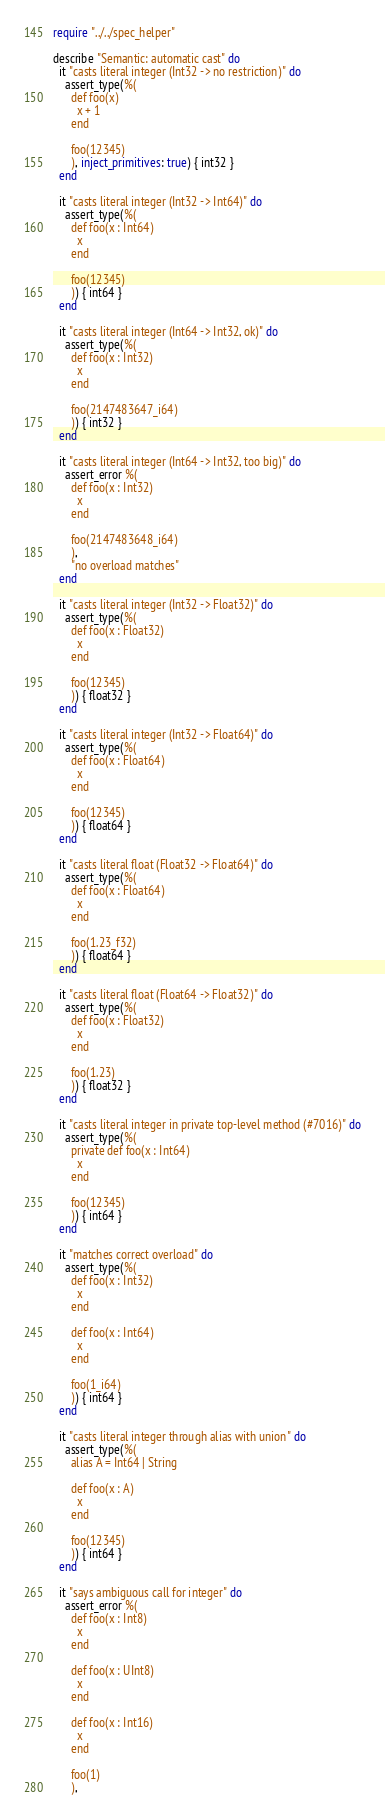<code> <loc_0><loc_0><loc_500><loc_500><_Crystal_>require "../../spec_helper"

describe "Semantic: automatic cast" do
  it "casts literal integer (Int32 -> no restriction)" do
    assert_type(%(
      def foo(x)
        x + 1
      end

      foo(12345)
      ), inject_primitives: true) { int32 }
  end

  it "casts literal integer (Int32 -> Int64)" do
    assert_type(%(
      def foo(x : Int64)
        x
      end

      foo(12345)
      )) { int64 }
  end

  it "casts literal integer (Int64 -> Int32, ok)" do
    assert_type(%(
      def foo(x : Int32)
        x
      end

      foo(2147483647_i64)
      )) { int32 }
  end

  it "casts literal integer (Int64 -> Int32, too big)" do
    assert_error %(
      def foo(x : Int32)
        x
      end

      foo(2147483648_i64)
      ),
      "no overload matches"
  end

  it "casts literal integer (Int32 -> Float32)" do
    assert_type(%(
      def foo(x : Float32)
        x
      end

      foo(12345)
      )) { float32 }
  end

  it "casts literal integer (Int32 -> Float64)" do
    assert_type(%(
      def foo(x : Float64)
        x
      end

      foo(12345)
      )) { float64 }
  end

  it "casts literal float (Float32 -> Float64)" do
    assert_type(%(
      def foo(x : Float64)
        x
      end

      foo(1.23_f32)
      )) { float64 }
  end

  it "casts literal float (Float64 -> Float32)" do
    assert_type(%(
      def foo(x : Float32)
        x
      end

      foo(1.23)
      )) { float32 }
  end

  it "casts literal integer in private top-level method (#7016)" do
    assert_type(%(
      private def foo(x : Int64)
        x
      end

      foo(12345)
      )) { int64 }
  end

  it "matches correct overload" do
    assert_type(%(
      def foo(x : Int32)
        x
      end

      def foo(x : Int64)
        x
      end

      foo(1_i64)
      )) { int64 }
  end

  it "casts literal integer through alias with union" do
    assert_type(%(
      alias A = Int64 | String

      def foo(x : A)
        x
      end

      foo(12345)
      )) { int64 }
  end

  it "says ambiguous call for integer" do
    assert_error %(
      def foo(x : Int8)
        x
      end

      def foo(x : UInt8)
        x
      end

      def foo(x : Int16)
        x
      end

      foo(1)
      ),</code> 